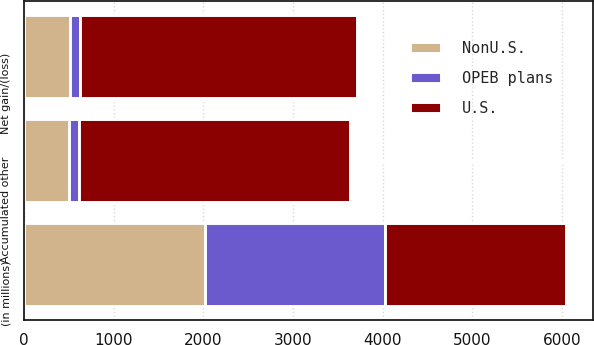Convert chart. <chart><loc_0><loc_0><loc_500><loc_500><stacked_bar_chart><ecel><fcel>(in millions)<fcel>Net gain/(loss)<fcel>Accumulated other<nl><fcel>U.S.<fcel>2015<fcel>3096<fcel>3028<nl><fcel>NonU.S.<fcel>2015<fcel>513<fcel>504<nl><fcel>OPEB plans<fcel>2015<fcel>109<fcel>109<nl></chart> 